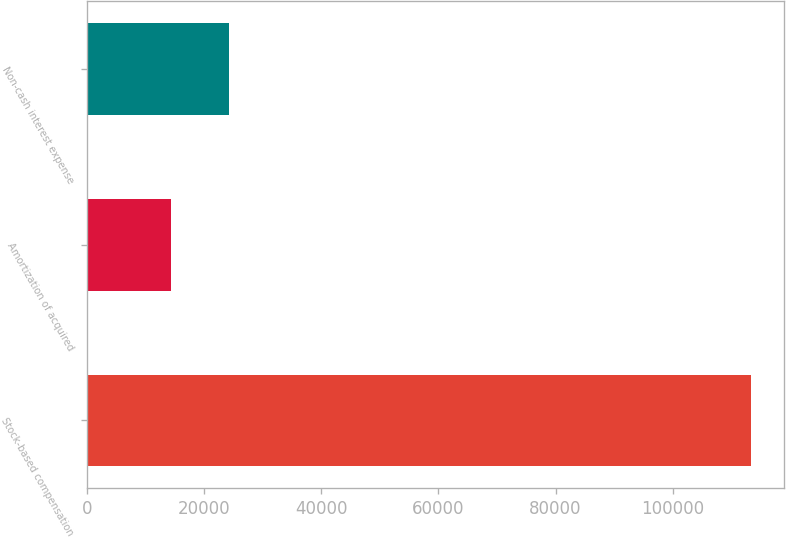Convert chart to OTSL. <chart><loc_0><loc_0><loc_500><loc_500><bar_chart><fcel>Stock-based compensation<fcel>Amortization of acquired<fcel>Non-cash interest expense<nl><fcel>113396<fcel>14340<fcel>24245.6<nl></chart> 